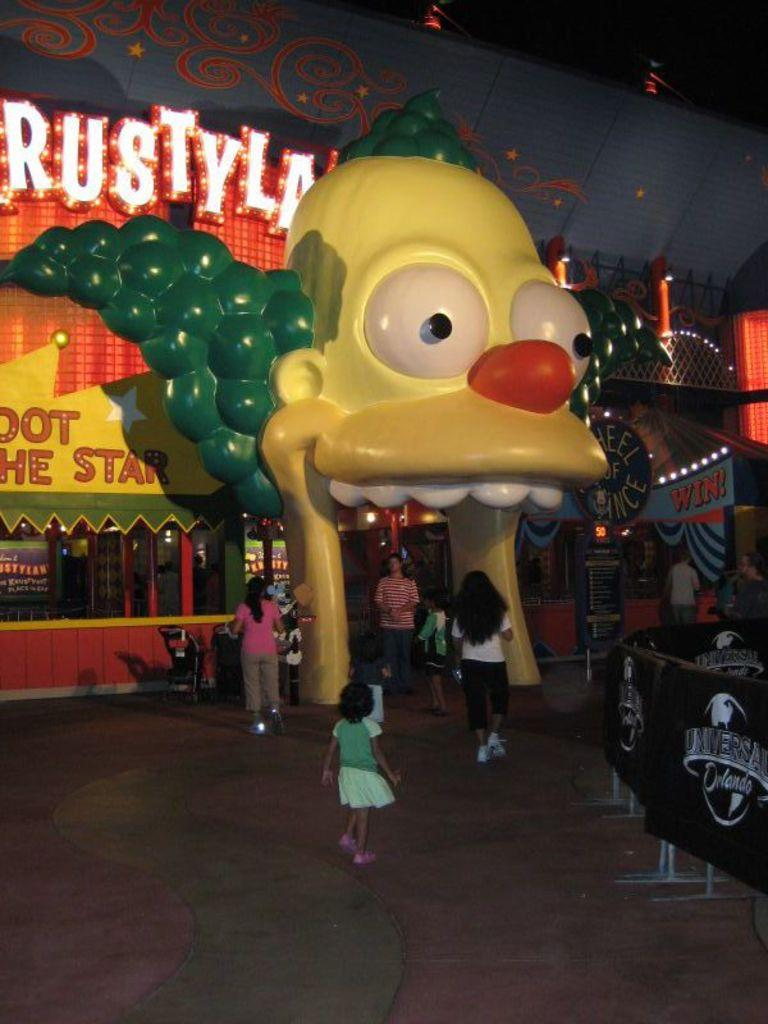What is the main subject of the image? The main subject of the image is the entrance of an adventure room. Are there any people in the image? Yes, there are people in front of the entrance. What kind of decoration is on the entrance? There is a joker-like structure on the entrance. What type of church can be seen in the image? There is no church present in the image; it features the entrance of an adventure room. What kind of quartz is visible on the joker-like structure? There is no quartz present on the joker-like structure in the image. 